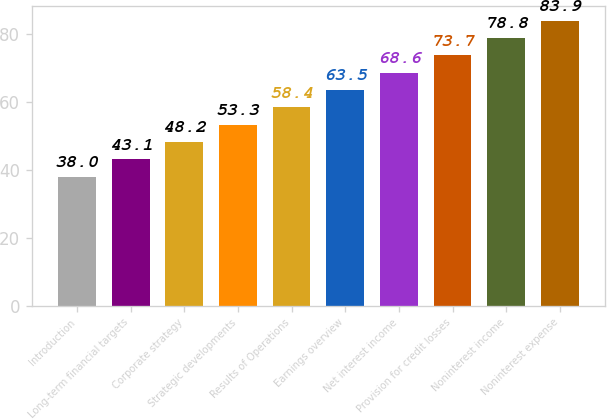Convert chart to OTSL. <chart><loc_0><loc_0><loc_500><loc_500><bar_chart><fcel>Introduction<fcel>Long-term financial targets<fcel>Corporate strategy<fcel>Strategic developments<fcel>Results of Operations<fcel>Earnings overview<fcel>Net interest income<fcel>Provision for credit losses<fcel>Noninterest income<fcel>Noninterest expense<nl><fcel>38<fcel>43.1<fcel>48.2<fcel>53.3<fcel>58.4<fcel>63.5<fcel>68.6<fcel>73.7<fcel>78.8<fcel>83.9<nl></chart> 